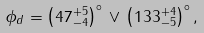Convert formula to latex. <formula><loc_0><loc_0><loc_500><loc_500>\phi _ { d } = \left ( 4 7 ^ { + 5 } _ { - 4 } \right ) ^ { \circ } \, \lor \, \left ( 1 3 3 ^ { + 4 } _ { - 5 } \right ) ^ { \circ } ,</formula> 